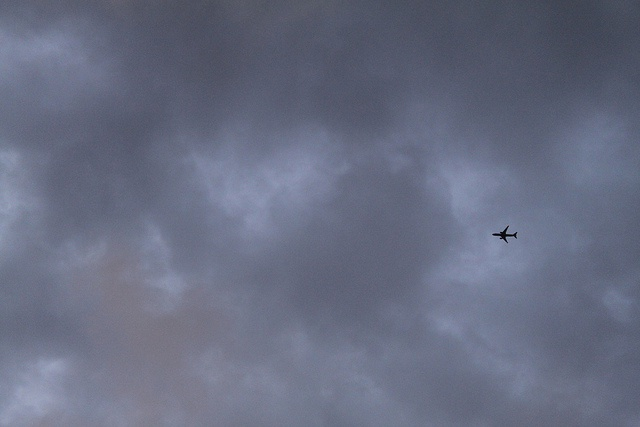Describe the objects in this image and their specific colors. I can see a airplane in gray and black tones in this image. 